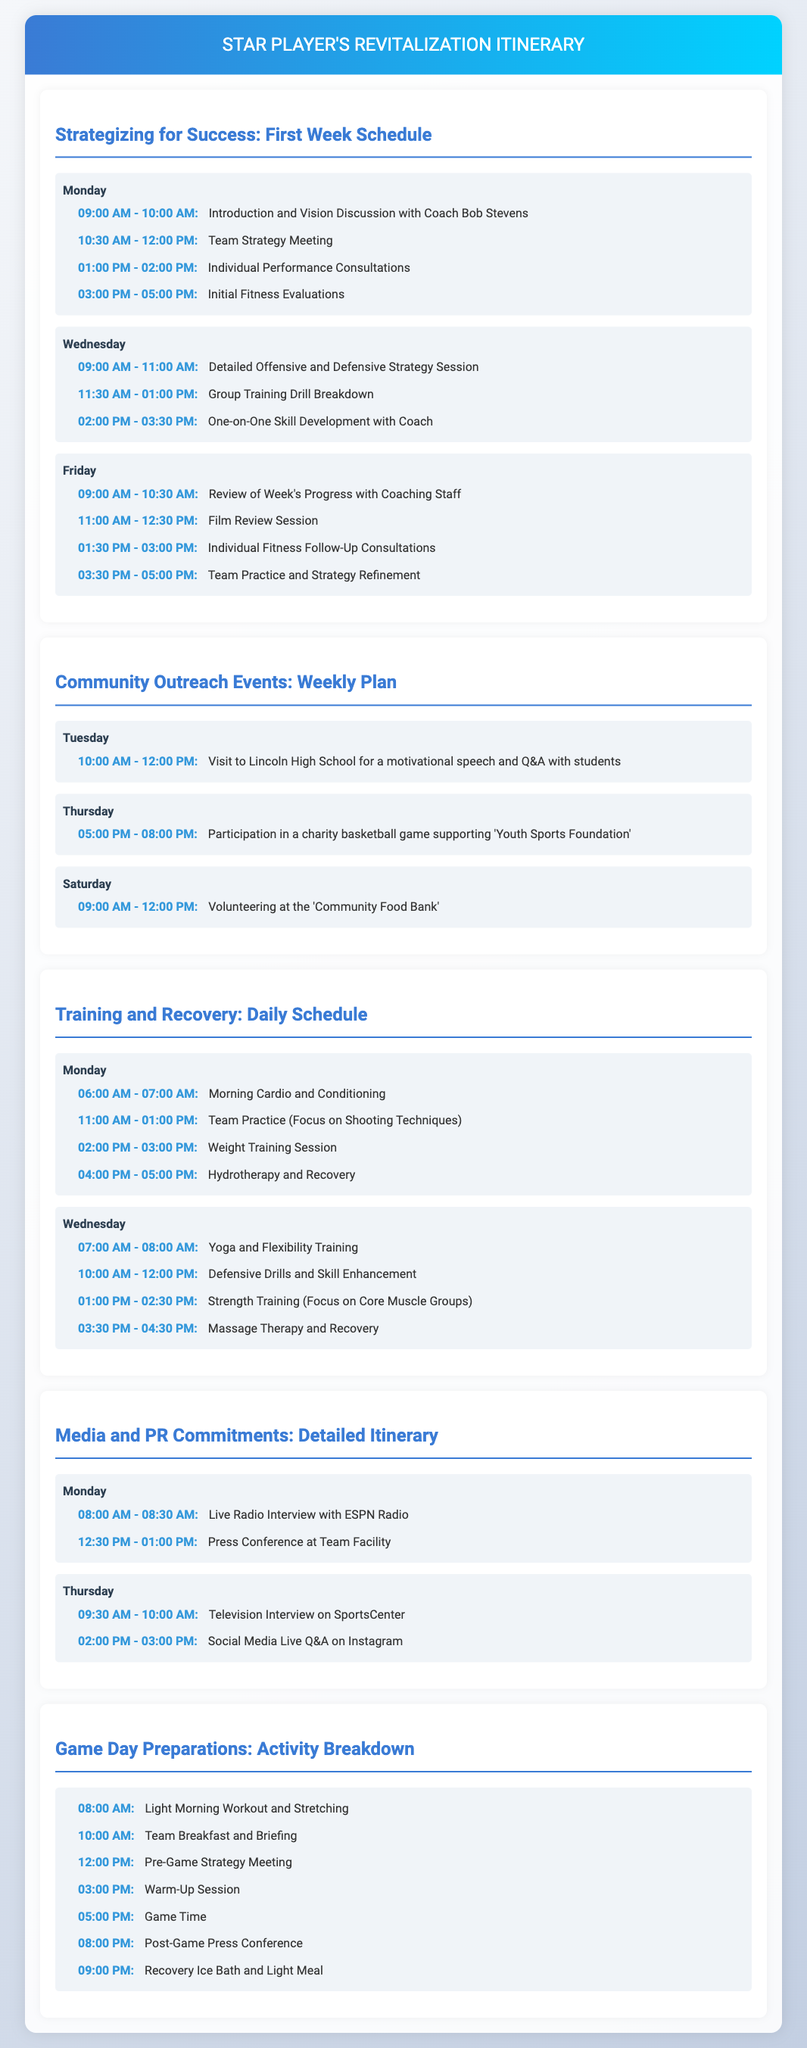What is the name of the new coach? The document mentions the new coach's name, which is Bob Stevens.
Answer: Bob Stevens What activity is scheduled for Tuesday morning? The itinerary indicates a specific event on Tuesday, which is the visit to Lincoln High School.
Answer: Visit to Lincoln High School How many press commitments are scheduled for Monday? The document outlines two media activities on Monday, requiring arithmetic reasoning.
Answer: 2 What time is the pre-game strategy meeting? The scheduling indicates the time for the pre-game strategy meeting, which is a specific point in the day's timeline.
Answer: 12:00 PM What is the focus during the Monday team practice? The document highlights the focus for the team practice on Monday, pointing to specific skill development.
Answer: Shooting Techniques Which day includes individual fitness follow-up consultations? The itinerary specifies when individual fitness consultations are set, requiring the reader to connect activities.
Answer: Friday What type of event is scheduled for Thursday evening? The document states the nature of the event on Thursday evening, detailing the specifics of the community outreach.
Answer: Charity basketball game How long is the live radio interview on Monday? The itinerary specifies the duration of the radio interview, which is clearly stated in the media commitments section.
Answer: 30 minutes 